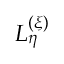<formula> <loc_0><loc_0><loc_500><loc_500>L _ { \eta } ^ { ( \xi ) }</formula> 